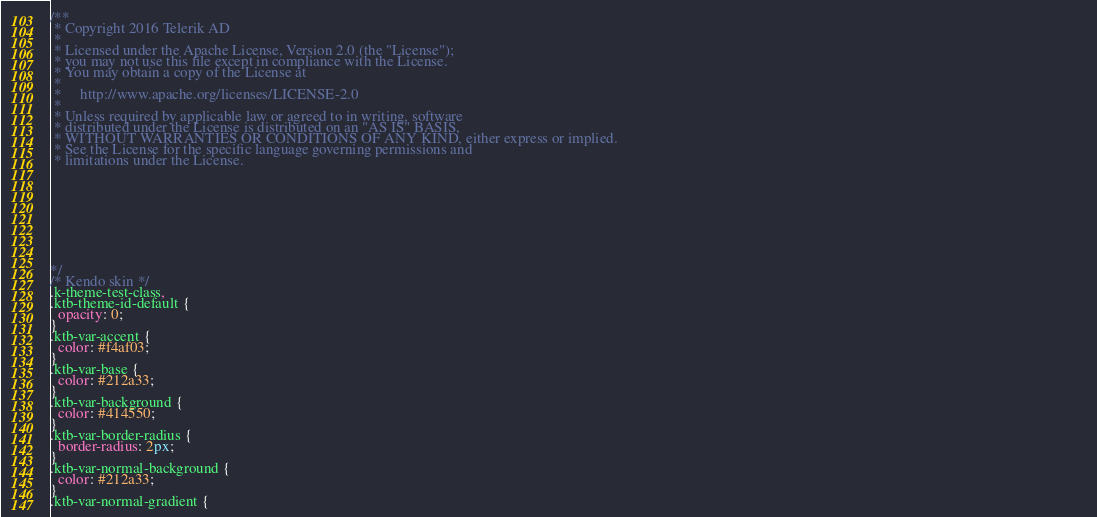<code> <loc_0><loc_0><loc_500><loc_500><_CSS_>/** 
 * Copyright 2016 Telerik AD                                                                                                                                                                            
 *                                                                                                                                                                                                      
 * Licensed under the Apache License, Version 2.0 (the "License");                                                                                                                                      
 * you may not use this file except in compliance with the License.                                                                                                                                     
 * You may obtain a copy of the License at                                                                                                                                                              
 *                                                                                                                                                                                                      
 *     http://www.apache.org/licenses/LICENSE-2.0                                                                                                                                                       
 *                                                                                                                                                                                                      
 * Unless required by applicable law or agreed to in writing, software                                                                                                                                  
 * distributed under the License is distributed on an "AS IS" BASIS,                                                                                                                                    
 * WITHOUT WARRANTIES OR CONDITIONS OF ANY KIND, either express or implied.                                                                                                                             
 * See the License for the specific language governing permissions and                                                                                                                                  
 * limitations under the License.                                                                                                                                                                       
                                                                                                                                                                                                       
                                                                                                                                                                                                       
                                                                                                                                                                                                       
                                                                                                                                                                                                       
                                                                                                                                                                                                       
                                                                                                                                                                                                       
                                                                                                                                                                                                       
                                                                                                                                                                                                       

*/
/* Kendo skin */
.k-theme-test-class,
.ktb-theme-id-default {
  opacity: 0;
}
.ktb-var-accent {
  color: #f4af03;
}
.ktb-var-base {
  color: #212a33;
}
.ktb-var-background {
  color: #414550;
}
.ktb-var-border-radius {
  border-radius: 2px;
}
.ktb-var-normal-background {
  color: #212a33;
}
.ktb-var-normal-gradient {</code> 